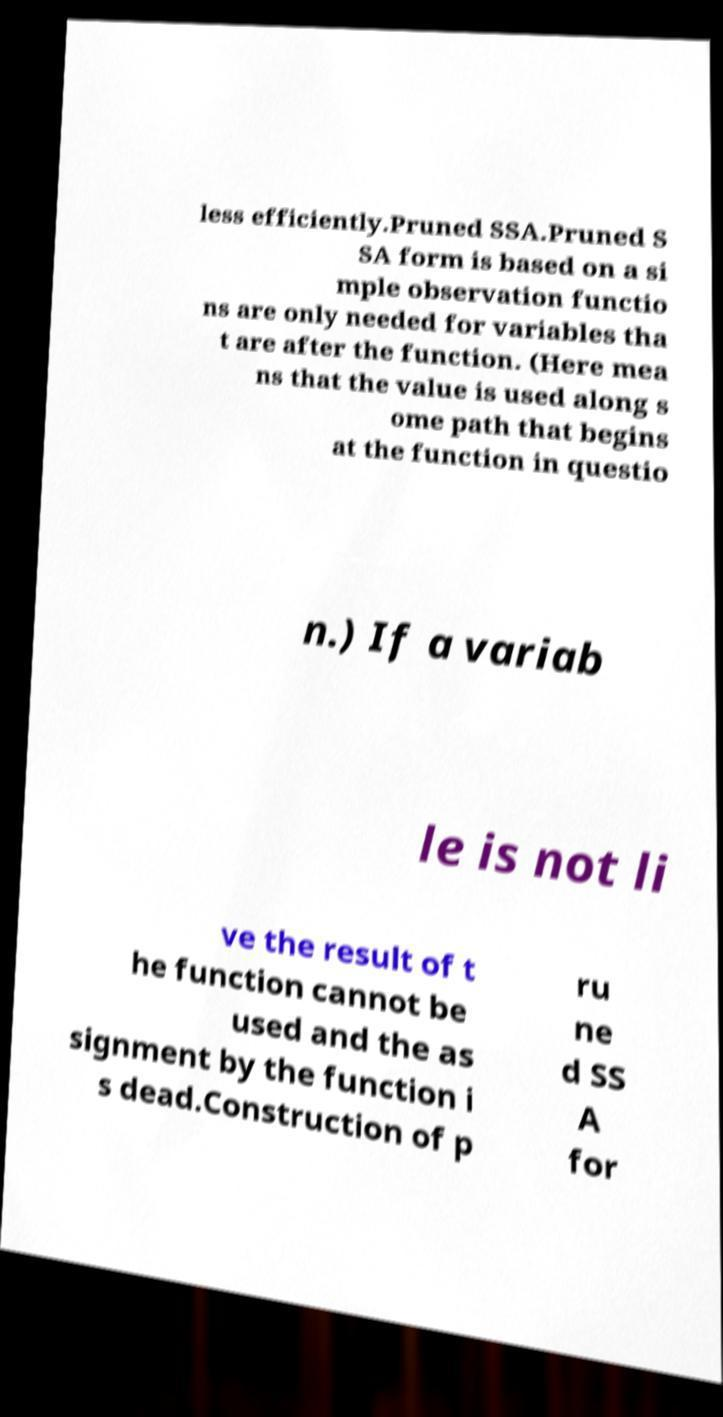Can you accurately transcribe the text from the provided image for me? less efficiently.Pruned SSA.Pruned S SA form is based on a si mple observation functio ns are only needed for variables tha t are after the function. (Here mea ns that the value is used along s ome path that begins at the function in questio n.) If a variab le is not li ve the result of t he function cannot be used and the as signment by the function i s dead.Construction of p ru ne d SS A for 